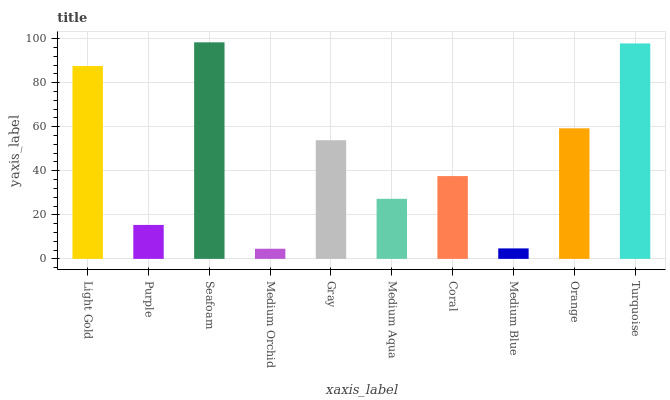Is Medium Orchid the minimum?
Answer yes or no. Yes. Is Seafoam the maximum?
Answer yes or no. Yes. Is Purple the minimum?
Answer yes or no. No. Is Purple the maximum?
Answer yes or no. No. Is Light Gold greater than Purple?
Answer yes or no. Yes. Is Purple less than Light Gold?
Answer yes or no. Yes. Is Purple greater than Light Gold?
Answer yes or no. No. Is Light Gold less than Purple?
Answer yes or no. No. Is Gray the high median?
Answer yes or no. Yes. Is Coral the low median?
Answer yes or no. Yes. Is Purple the high median?
Answer yes or no. No. Is Light Gold the low median?
Answer yes or no. No. 